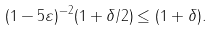<formula> <loc_0><loc_0><loc_500><loc_500>( 1 - 5 \varepsilon ) ^ { - 2 } ( 1 + \delta / 2 ) \leq ( 1 + \delta ) .</formula> 